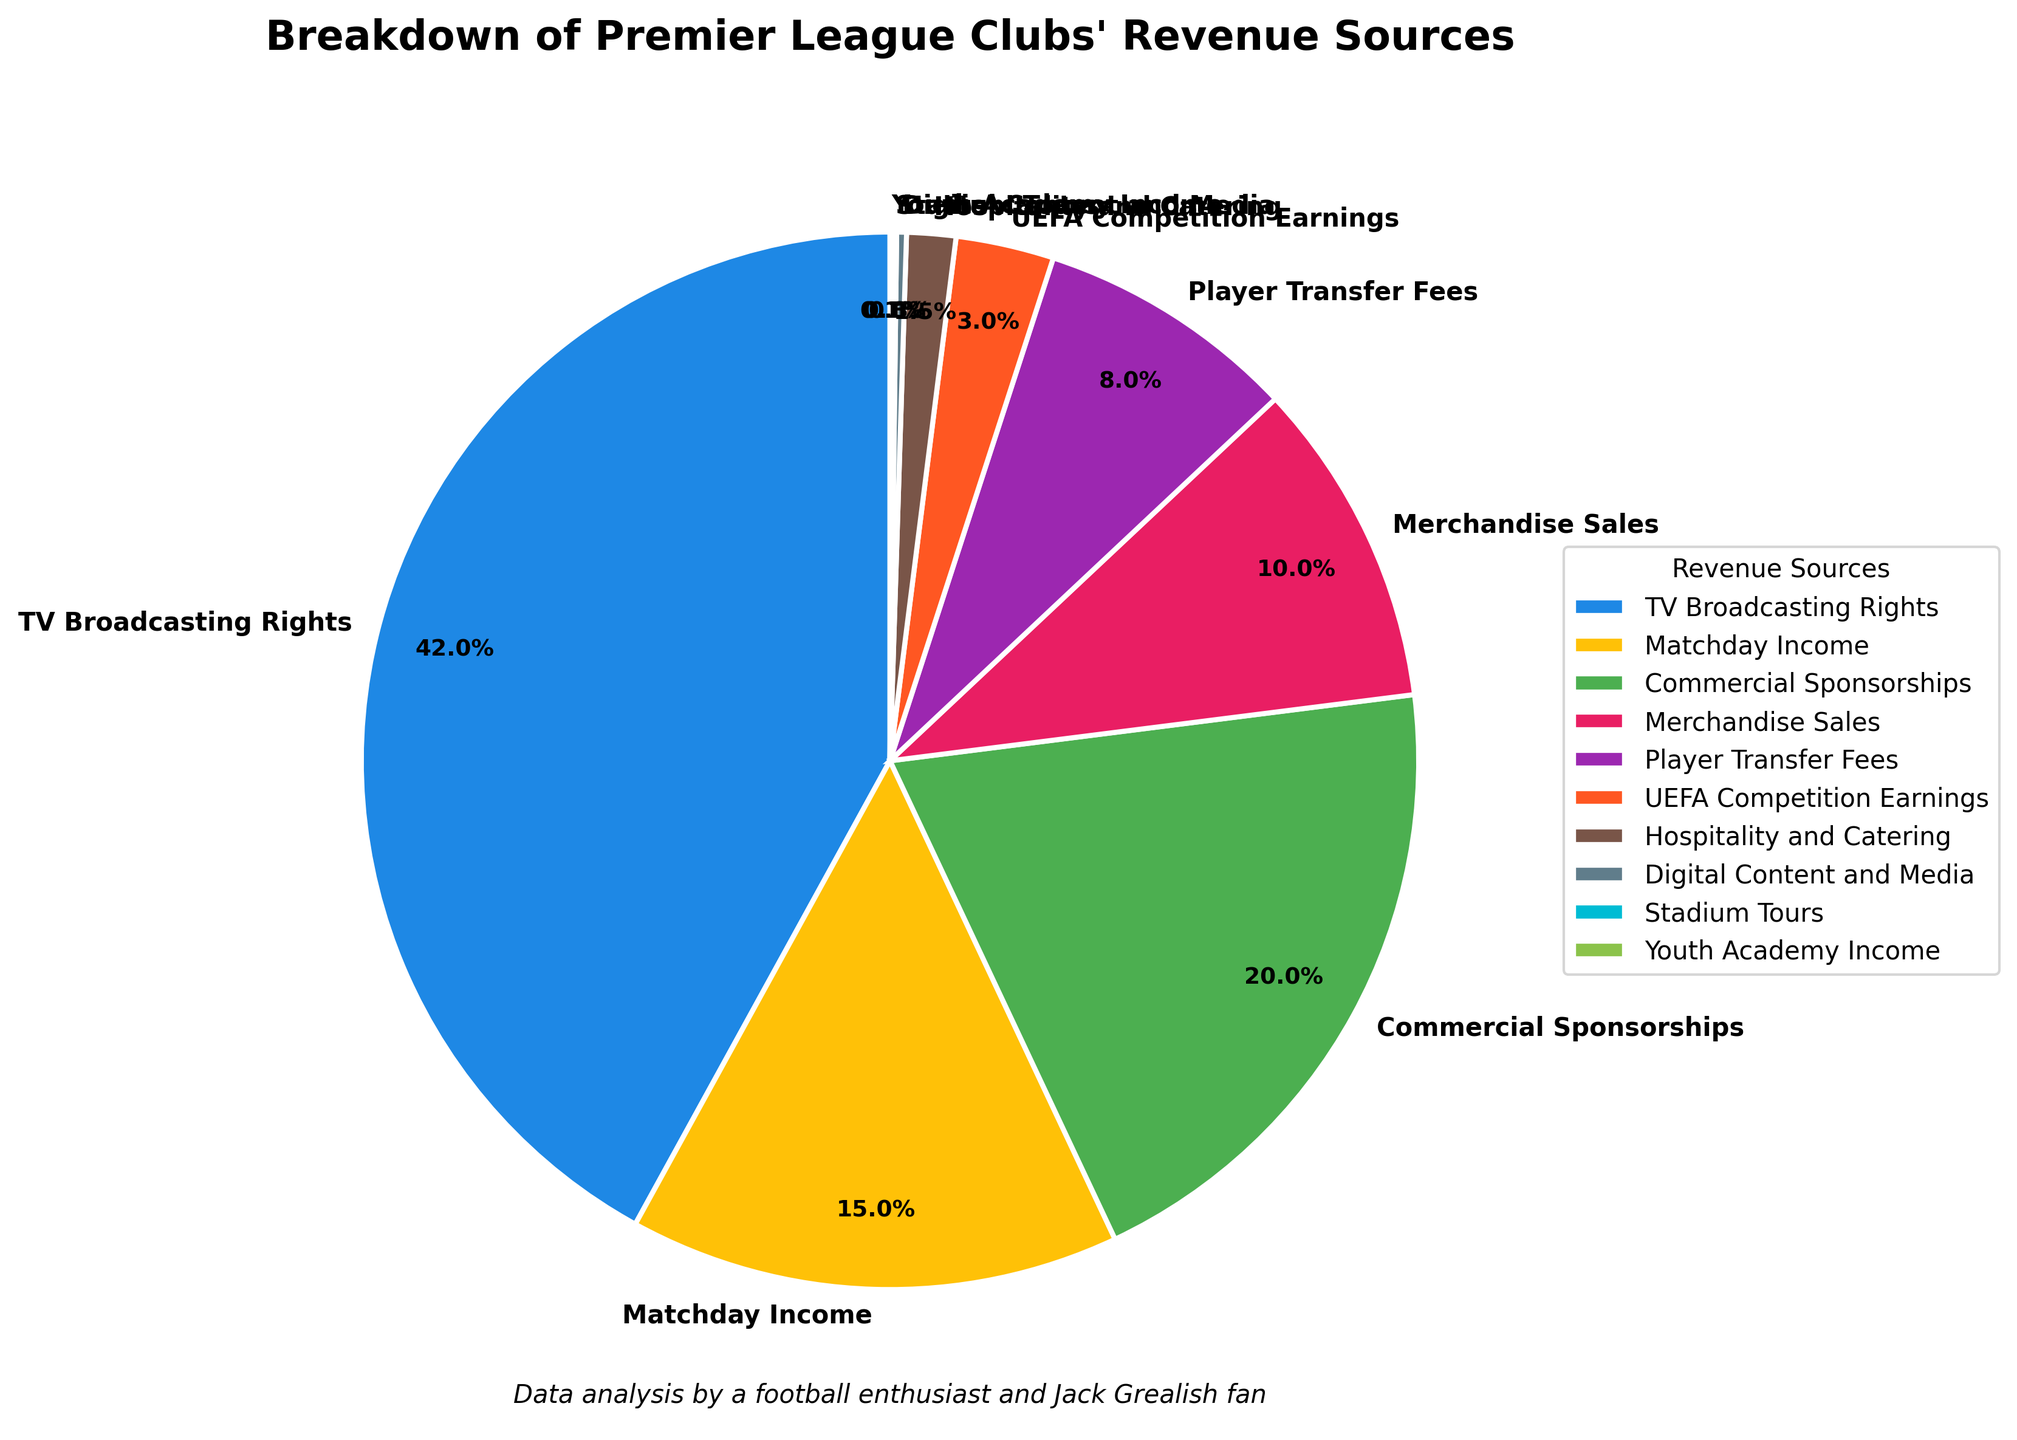What is the revenue source with the highest percentage? The revenue source with the highest percentage can be identified by looking for the largest slice in the pie chart. The label associated with the largest slice is "TV Broadcasting Rights" which has 42%.
Answer: TV Broadcasting Rights Which two revenue sources together make up just over half of the total revenue? To find the two revenue sources that together constitute just over half, sum the percentages of the largest slices until the sum exceeds 50%. "TV Broadcasting Rights" is 42%, and "Commercial Sponsorships" is 20%. Adding these up, 42 + 20 = 62%, which is just over half of the total.
Answer: TV Broadcasting Rights, Commercial Sponsorships What percentage of the total revenue comes from matchday-related activities? To find the percentage from matchday-related activities, sum the percentages of "Matchday Income," "Hospitality and Catering," and "Stadium Tours." 15% (Matchday Income) + 1.5% (Hospitality and Catering) + 0.1% (Stadium Tours) = 16.6%.
Answer: 16.6% How does the revenue from commercial sponsorships compare to revenue from merchandise sales? First, identify the percentages for "Commercial Sponsorships" and "Merchandise Sales." Commercial Sponsorships is 20% and Merchandise Sales is 10%. Comparing the two, 20% is greater than 10%.
Answer: Commercial Sponsorships > Merchandise Sales Which revenue source has the smallest percentage? The revenue sources with small percentages can be identified by looking for the smallest slices. The smallest slices are "Stadium Tours" and "Youth Academy Income," each with 0.1%.
Answer: Stadium Tours, Youth Academy Income What is the combined percentage of the three smallest revenue sources? Identify the percentages of the three smallest revenue sources: "Stadium Tours" (0.1%), "Youth Academy Income" (0.1%), and "Digital Content and Media" (0.3%). Adding these, 0.1 + 0.1 + 0.3 = 0.5%.
Answer: 0.5% How does the percentage of revenue from player transfer fees compare to that from matchday income? First, identify the percentages for "Player Transfer Fees" and "Matchday Income" from the chart. Player Transfer Fees is 8% and Matchday Income is 15%. Comparing, 8% is less than 15%.
Answer: Player Transfer Fees < Matchday Income Which revenue sources are less than 5% each? Identify the slices with percentages less than 5%. The sources that are below this threshold are "Player Transfer Fees" (8% not included), "UEFA Competition Earnings" (3%), "Hospitality and Catering" (1.5%), "Digital Content and Media" (0.3%), "Stadium Tours" (0.1%), and "Youth Academy Income" (0.1%).
Answer: UEFA Competition Earnings, Hospitality and Catering, Digital Content and Media, Stadium Tours, Youth Academy Income What percentage more comes from TV Broadcasting Rights than from Commercial Sponsorships? First, identify the percentages for "TV Broadcasting Rights" and "Commercial Sponsorships." TV Broadcasting Rights is 42% and Commercial Sponsorships is 20%. Subtract the smaller percentage from the larger one: 42% - 20% = 22%.
Answer: 22% What is the average percentage of revenue from Commercial Sponsorships, Merchandise Sales, and Player Transfer Fees? To find the average, sum the percentages of the three sources and divide by the number of sources. The percentages are 20% (Commercial Sponsorships), 10% (Merchandise Sales), and 8% (Player Transfer Fees). Sum these, 20 + 10 + 8 = 38. Then divide by 3, 38 ÷ 3 ≈ 12.67%.
Answer: 12.67% 